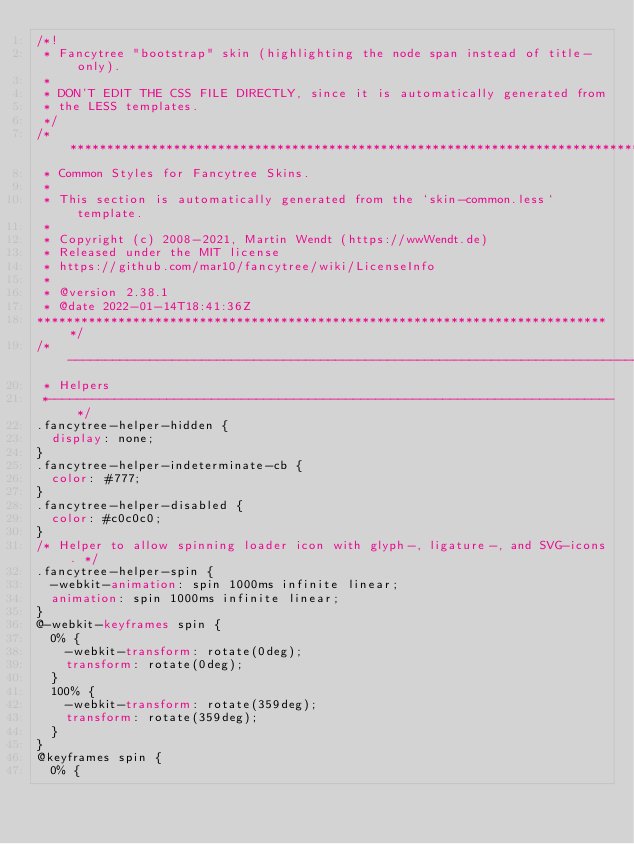Convert code to text. <code><loc_0><loc_0><loc_500><loc_500><_CSS_>/*!
 * Fancytree "bootstrap" skin (highlighting the node span instead of title-only).
 *
 * DON'T EDIT THE CSS FILE DIRECTLY, since it is automatically generated from
 * the LESS templates.
 */
/*******************************************************************************
 * Common Styles for Fancytree Skins.
 *
 * This section is automatically generated from the `skin-common.less` template.
 *
 * Copyright (c) 2008-2021, Martin Wendt (https://wwWendt.de)
 * Released under the MIT license
 * https://github.com/mar10/fancytree/wiki/LicenseInfo
 *
 * @version 2.38.1
 * @date 2022-01-14T18:41:36Z
******************************************************************************/
/*------------------------------------------------------------------------------
 * Helpers
 *----------------------------------------------------------------------------*/
.fancytree-helper-hidden {
  display: none;
}
.fancytree-helper-indeterminate-cb {
  color: #777;
}
.fancytree-helper-disabled {
  color: #c0c0c0;
}
/* Helper to allow spinning loader icon with glyph-, ligature-, and SVG-icons. */
.fancytree-helper-spin {
  -webkit-animation: spin 1000ms infinite linear;
  animation: spin 1000ms infinite linear;
}
@-webkit-keyframes spin {
  0% {
    -webkit-transform: rotate(0deg);
    transform: rotate(0deg);
  }
  100% {
    -webkit-transform: rotate(359deg);
    transform: rotate(359deg);
  }
}
@keyframes spin {
  0% {</code> 